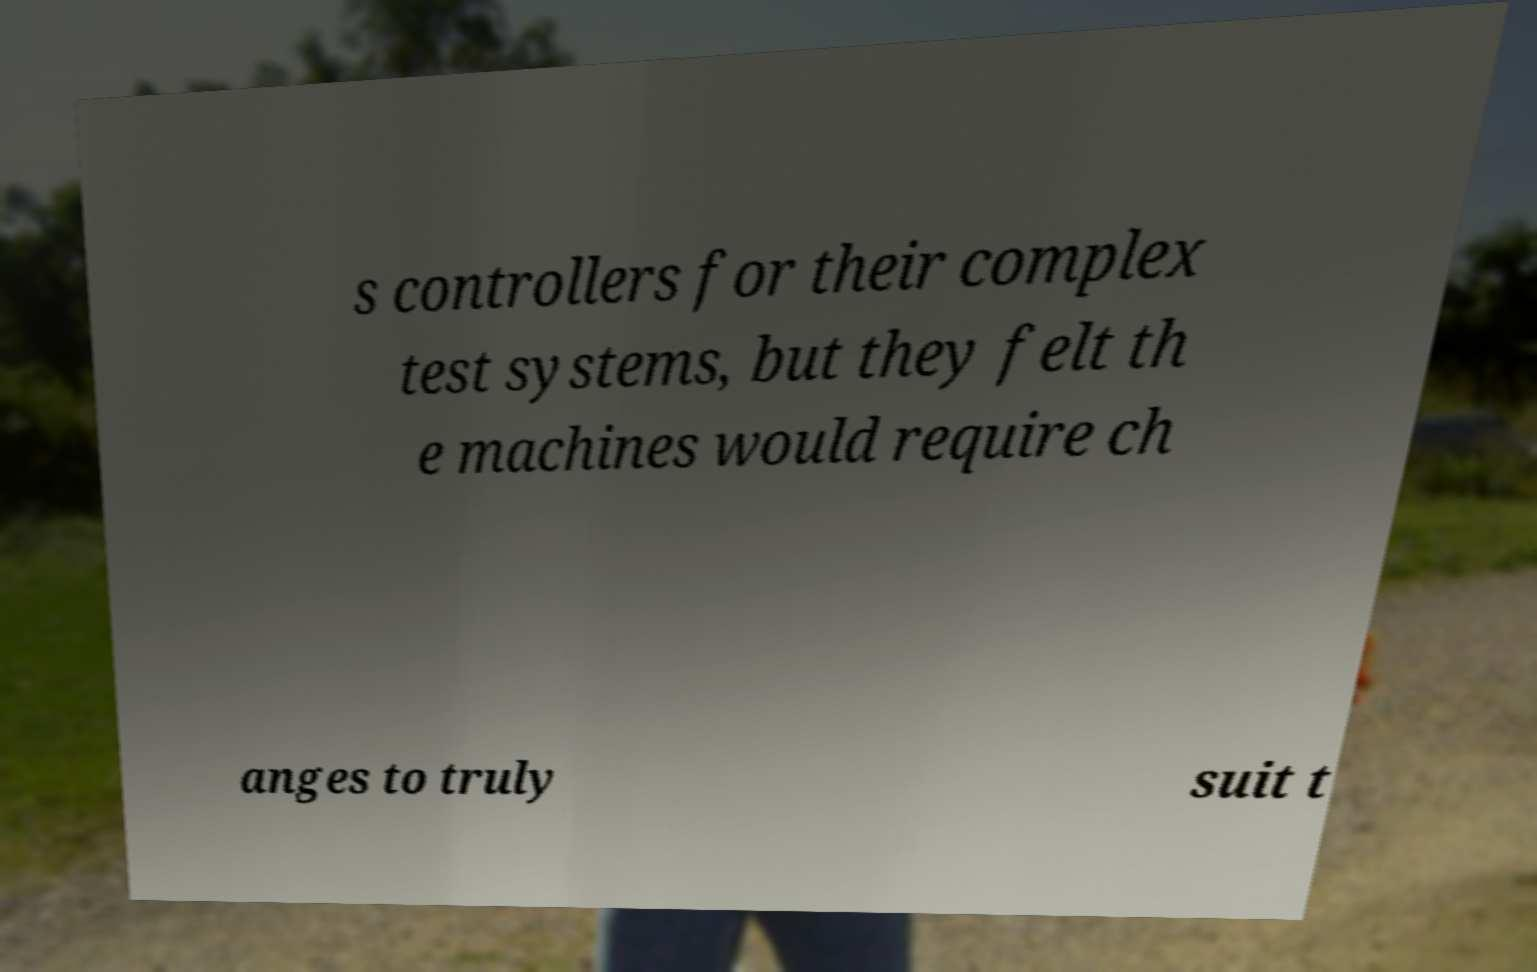I need the written content from this picture converted into text. Can you do that? s controllers for their complex test systems, but they felt th e machines would require ch anges to truly suit t 